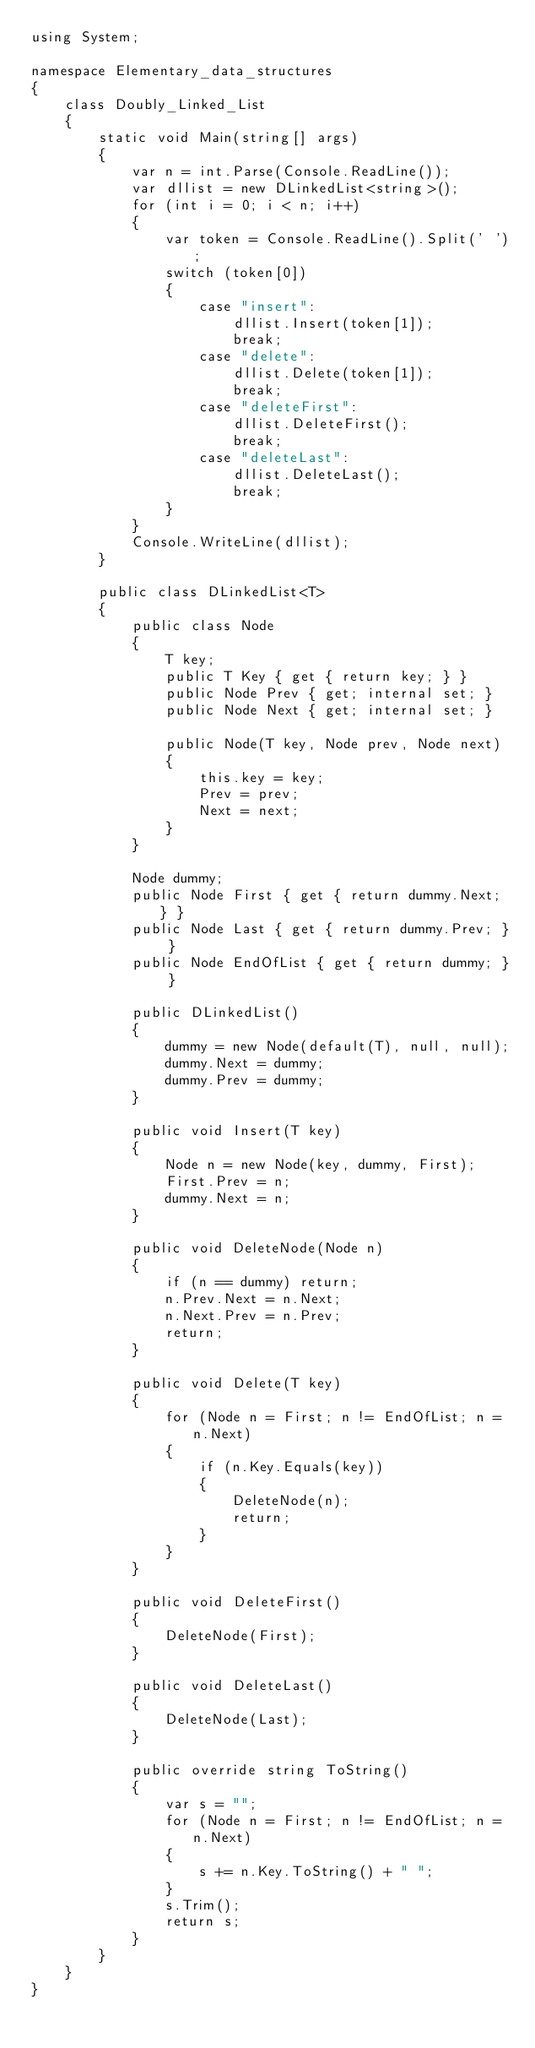Convert code to text. <code><loc_0><loc_0><loc_500><loc_500><_C#_>using System;

namespace Elementary_data_structures
{
    class Doubly_Linked_List
    {
        static void Main(string[] args)
        {
            var n = int.Parse(Console.ReadLine());
            var dllist = new DLinkedList<string>();
            for (int i = 0; i < n; i++)
            {
                var token = Console.ReadLine().Split(' ');
                switch (token[0])
                {
                    case "insert":
                        dllist.Insert(token[1]);
                        break;
                    case "delete":
                        dllist.Delete(token[1]);
                        break;
                    case "deleteFirst":
                        dllist.DeleteFirst();
                        break;
                    case "deleteLast":
                        dllist.DeleteLast();
                        break;
                }
            }
            Console.WriteLine(dllist);
        }

        public class DLinkedList<T>
        {
            public class Node
            {
                T key;
                public T Key { get { return key; } }
                public Node Prev { get; internal set; }
                public Node Next { get; internal set; }

                public Node(T key, Node prev, Node next)
                {
                    this.key = key;
                    Prev = prev;
                    Next = next;
                }
            }

            Node dummy;
            public Node First { get { return dummy.Next; } }
            public Node Last { get { return dummy.Prev; } }
            public Node EndOfList { get { return dummy; } }

            public DLinkedList()
            {
                dummy = new Node(default(T), null, null);
                dummy.Next = dummy;
                dummy.Prev = dummy;
            }

            public void Insert(T key)
            {
                Node n = new Node(key, dummy, First);
                First.Prev = n;
                dummy.Next = n;
            }

            public void DeleteNode(Node n)
            {
                if (n == dummy) return;
                n.Prev.Next = n.Next;
                n.Next.Prev = n.Prev;
                return;
            }

            public void Delete(T key)
            {
                for (Node n = First; n != EndOfList; n = n.Next)
                {
                    if (n.Key.Equals(key))
                    {
                        DeleteNode(n);
                        return;
                    }
                }
            }

            public void DeleteFirst()
            {
                DeleteNode(First);
            }

            public void DeleteLast()
            {
                DeleteNode(Last);
            }

            public override string ToString()
            {
                var s = "";
                for (Node n = First; n != EndOfList; n = n.Next)
                {
                    s += n.Key.ToString() + " ";
                }
                s.Trim();
                return s;
            }
        }
    }
}</code> 